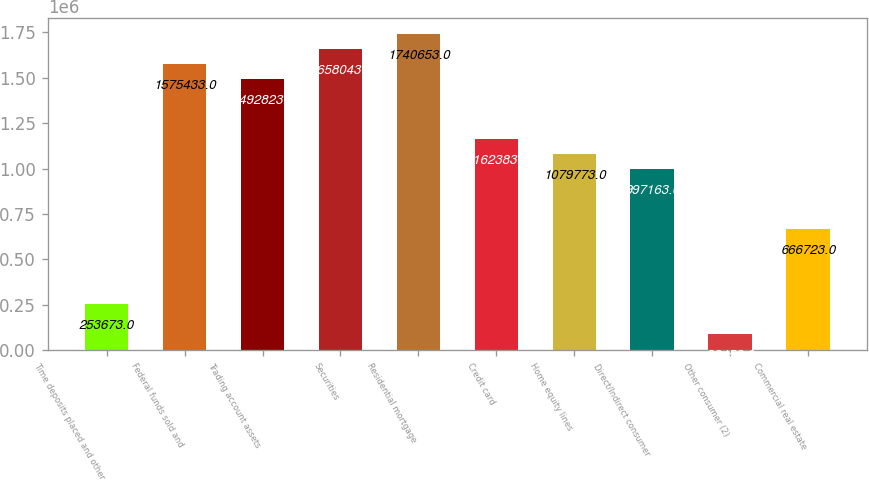Convert chart to OTSL. <chart><loc_0><loc_0><loc_500><loc_500><bar_chart><fcel>Time deposits placed and other<fcel>Federal funds sold and<fcel>Trading account assets<fcel>Securities<fcel>Residential mortgage<fcel>Credit card<fcel>Home equity lines<fcel>Direct/Indirect consumer<fcel>Other consumer (2)<fcel>Commercial real estate<nl><fcel>253673<fcel>1.57543e+06<fcel>1.49282e+06<fcel>1.65804e+06<fcel>1.74065e+06<fcel>1.16238e+06<fcel>1.07977e+06<fcel>997163<fcel>88453<fcel>666723<nl></chart> 